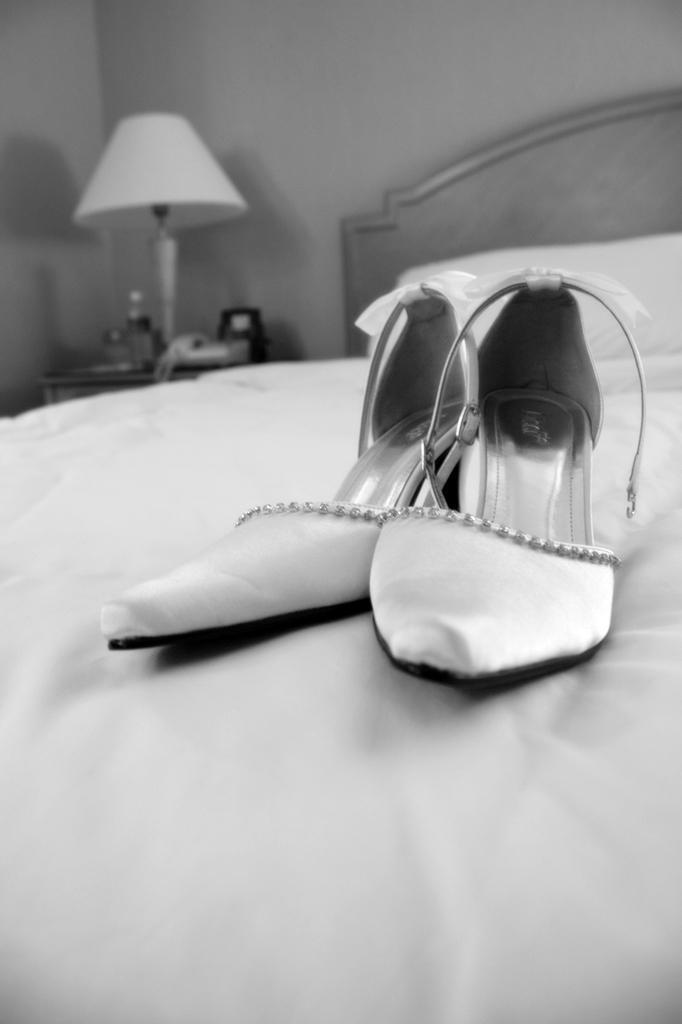Could you give a brief overview of what you see in this image? In this image I can see the footwear on the bed. I can also see the pillow in the bed. To the left there is a lamp, telephone and some objects on the table. In the background I can see the wall and this is black and white image. 